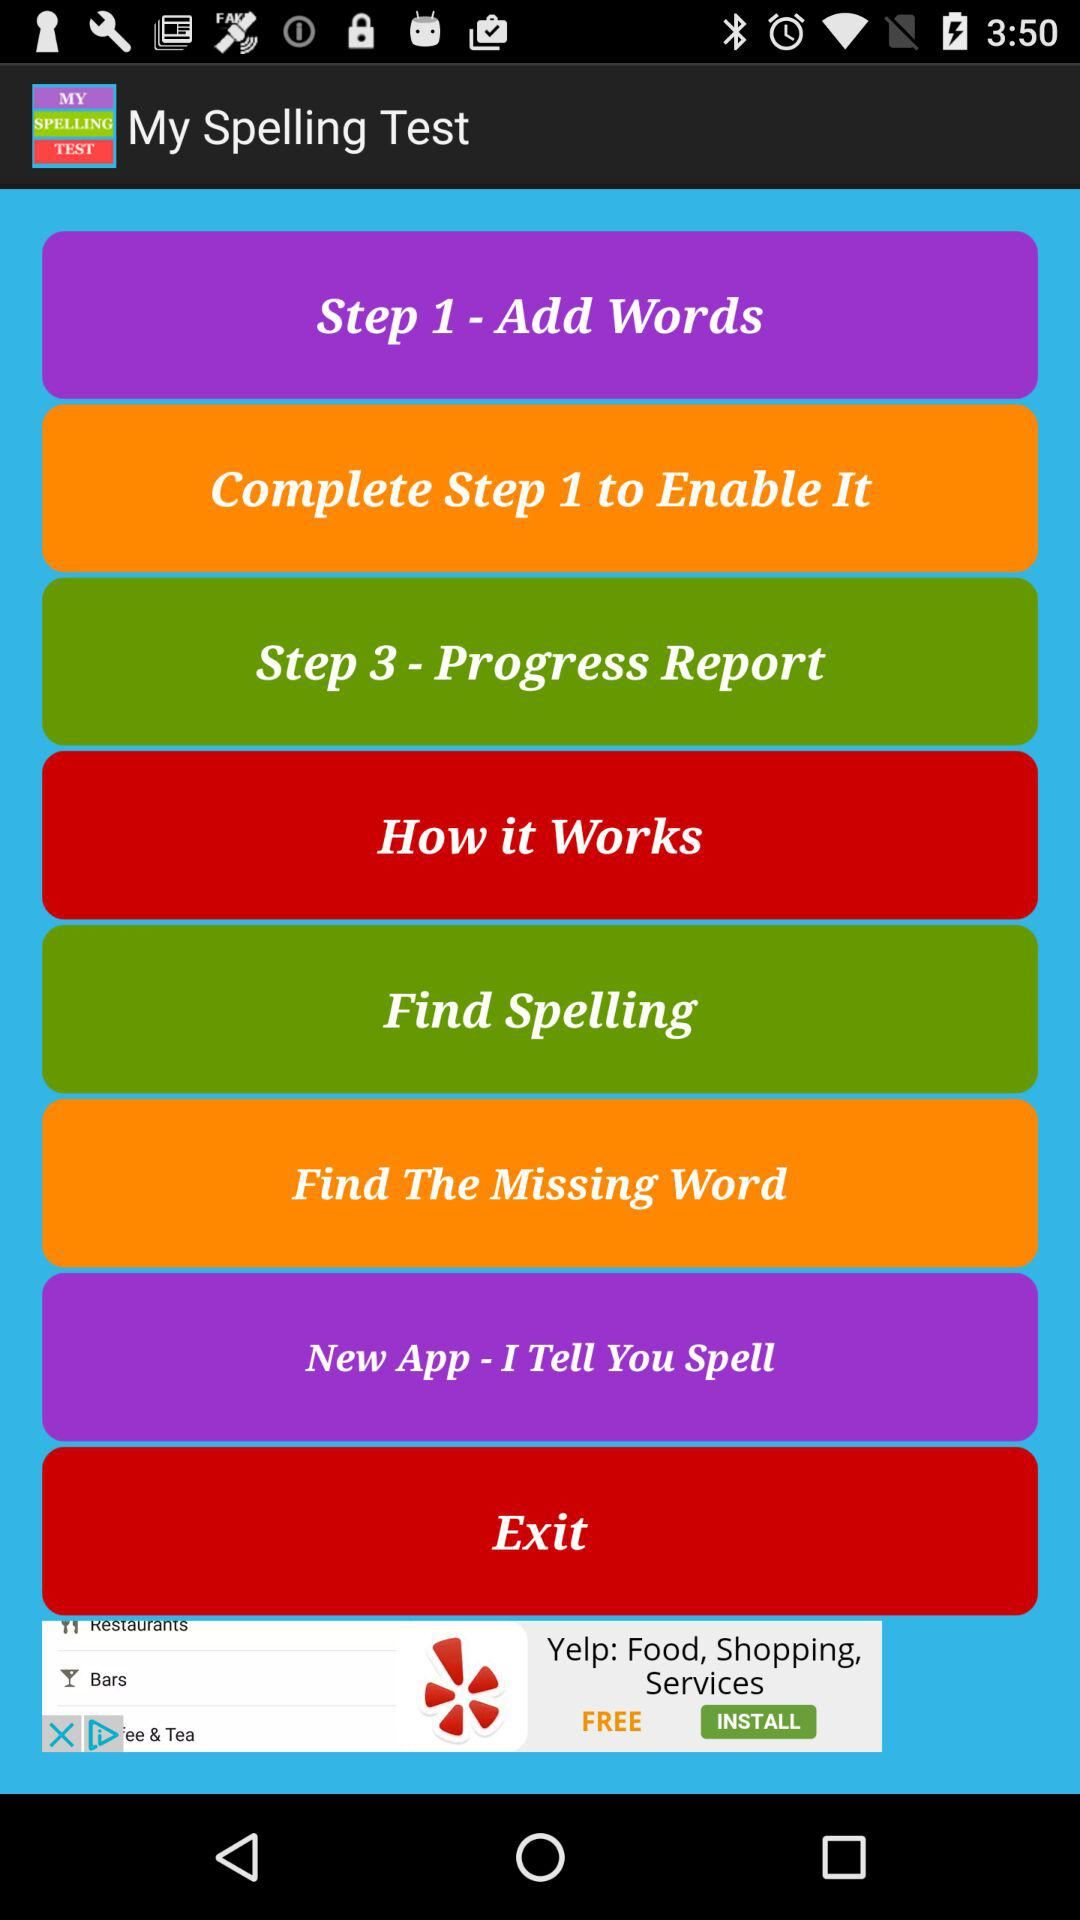Define step 3?
When the provided information is insufficient, respond with <no answer>. <no answer> 